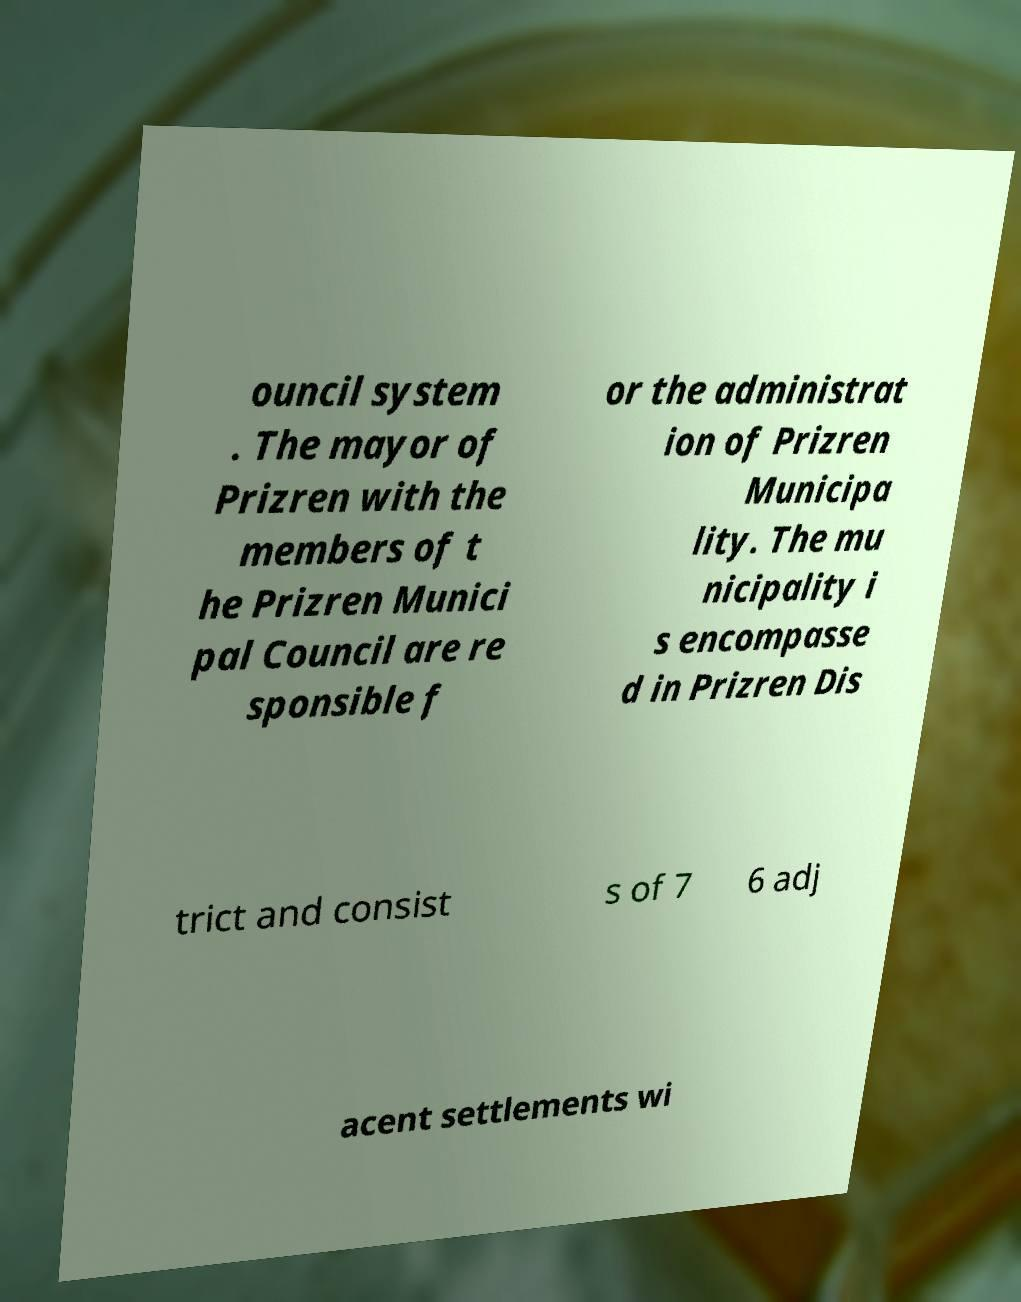Please read and relay the text visible in this image. What does it say? ouncil system . The mayor of Prizren with the members of t he Prizren Munici pal Council are re sponsible f or the administrat ion of Prizren Municipa lity. The mu nicipality i s encompasse d in Prizren Dis trict and consist s of 7 6 adj acent settlements wi 